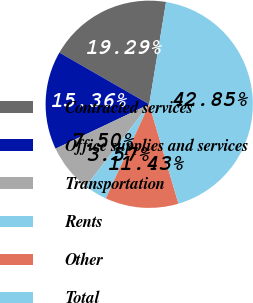Convert chart to OTSL. <chart><loc_0><loc_0><loc_500><loc_500><pie_chart><fcel>Contracted services<fcel>Office supplies and services<fcel>Transportation<fcel>Rents<fcel>Other<fcel>Total<nl><fcel>19.29%<fcel>15.36%<fcel>7.5%<fcel>3.57%<fcel>11.43%<fcel>42.85%<nl></chart> 